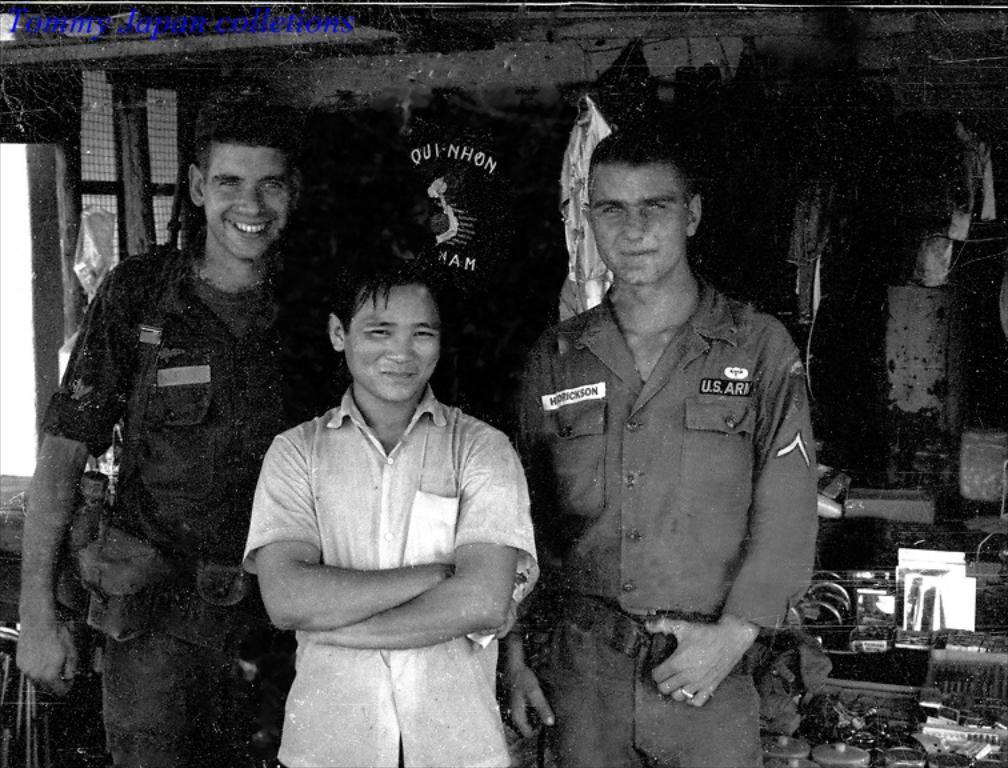Please provide a concise description of this image. In the center of the image we can see three persons are standing and they are smiling and they are in different costumes. In the background there is a wall, roof, banner, cloth, white color objects, round shape objects and a few other objects. At the top left side of the image, we can see some text. 